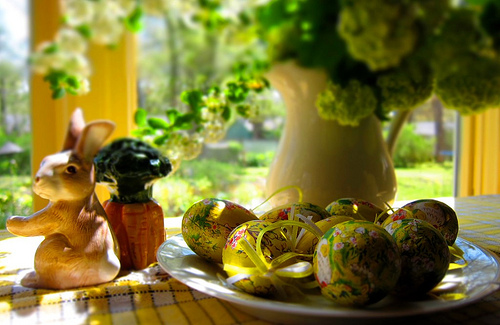<image>
Can you confirm if the rabbit is to the left of the table? No. The rabbit is not to the left of the table. From this viewpoint, they have a different horizontal relationship. 